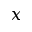<formula> <loc_0><loc_0><loc_500><loc_500>x</formula> 